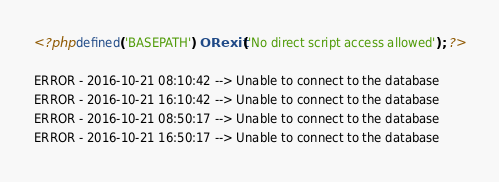<code> <loc_0><loc_0><loc_500><loc_500><_PHP_><?php defined('BASEPATH') OR exit('No direct script access allowed'); ?>

ERROR - 2016-10-21 08:10:42 --> Unable to connect to the database
ERROR - 2016-10-21 16:10:42 --> Unable to connect to the database
ERROR - 2016-10-21 08:50:17 --> Unable to connect to the database
ERROR - 2016-10-21 16:50:17 --> Unable to connect to the database
</code> 